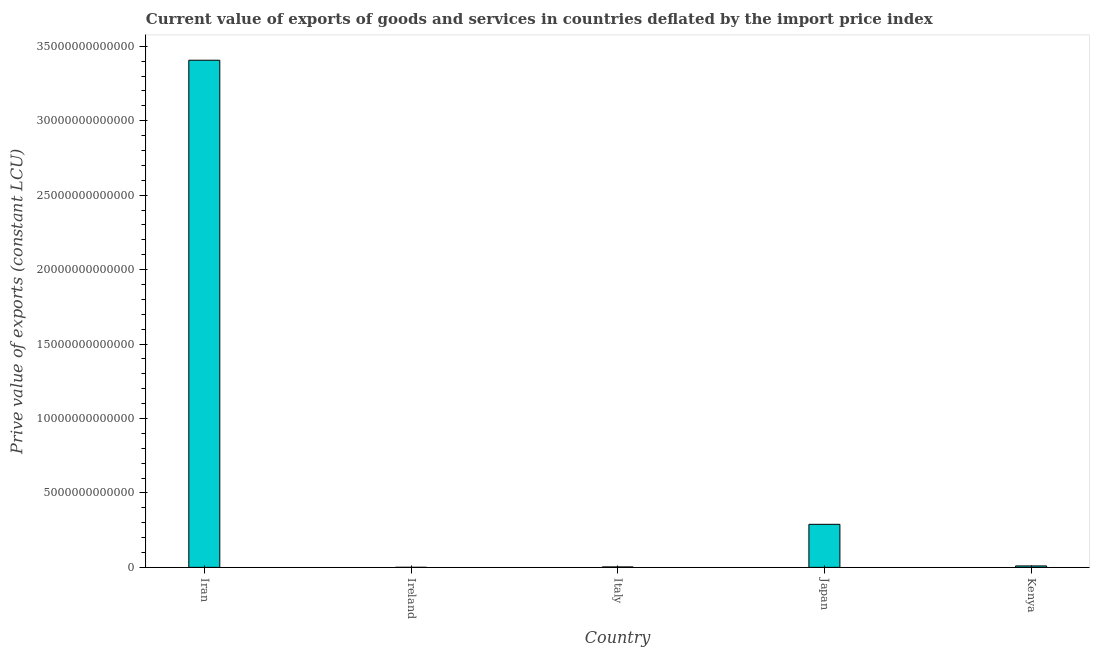Does the graph contain grids?
Give a very brief answer. No. What is the title of the graph?
Ensure brevity in your answer.  Current value of exports of goods and services in countries deflated by the import price index. What is the label or title of the Y-axis?
Provide a succinct answer. Prive value of exports (constant LCU). What is the price value of exports in Italy?
Make the answer very short. 2.88e+1. Across all countries, what is the maximum price value of exports?
Your answer should be very brief. 3.41e+13. Across all countries, what is the minimum price value of exports?
Your answer should be compact. 2.78e+09. In which country was the price value of exports maximum?
Keep it short and to the point. Iran. In which country was the price value of exports minimum?
Your response must be concise. Ireland. What is the sum of the price value of exports?
Offer a terse response. 3.71e+13. What is the difference between the price value of exports in Iran and Italy?
Offer a very short reply. 3.40e+13. What is the average price value of exports per country?
Give a very brief answer. 7.42e+12. What is the median price value of exports?
Your answer should be very brief. 9.59e+1. What is the ratio of the price value of exports in Iran to that in Kenya?
Keep it short and to the point. 355.28. Is the price value of exports in Iran less than that in Ireland?
Provide a short and direct response. No. Is the difference between the price value of exports in Japan and Kenya greater than the difference between any two countries?
Your answer should be very brief. No. What is the difference between the highest and the second highest price value of exports?
Provide a succinct answer. 3.12e+13. What is the difference between the highest and the lowest price value of exports?
Your response must be concise. 3.41e+13. In how many countries, is the price value of exports greater than the average price value of exports taken over all countries?
Make the answer very short. 1. How many bars are there?
Offer a very short reply. 5. Are all the bars in the graph horizontal?
Provide a succinct answer. No. How many countries are there in the graph?
Make the answer very short. 5. What is the difference between two consecutive major ticks on the Y-axis?
Provide a short and direct response. 5.00e+12. What is the Prive value of exports (constant LCU) in Iran?
Your answer should be compact. 3.41e+13. What is the Prive value of exports (constant LCU) of Ireland?
Provide a short and direct response. 2.78e+09. What is the Prive value of exports (constant LCU) of Italy?
Make the answer very short. 2.88e+1. What is the Prive value of exports (constant LCU) of Japan?
Give a very brief answer. 2.89e+12. What is the Prive value of exports (constant LCU) of Kenya?
Your answer should be compact. 9.59e+1. What is the difference between the Prive value of exports (constant LCU) in Iran and Ireland?
Your answer should be very brief. 3.41e+13. What is the difference between the Prive value of exports (constant LCU) in Iran and Italy?
Make the answer very short. 3.40e+13. What is the difference between the Prive value of exports (constant LCU) in Iran and Japan?
Your answer should be very brief. 3.12e+13. What is the difference between the Prive value of exports (constant LCU) in Iran and Kenya?
Your answer should be very brief. 3.40e+13. What is the difference between the Prive value of exports (constant LCU) in Ireland and Italy?
Your answer should be compact. -2.60e+1. What is the difference between the Prive value of exports (constant LCU) in Ireland and Japan?
Your answer should be compact. -2.89e+12. What is the difference between the Prive value of exports (constant LCU) in Ireland and Kenya?
Your answer should be very brief. -9.31e+1. What is the difference between the Prive value of exports (constant LCU) in Italy and Japan?
Provide a succinct answer. -2.86e+12. What is the difference between the Prive value of exports (constant LCU) in Italy and Kenya?
Provide a succinct answer. -6.71e+1. What is the difference between the Prive value of exports (constant LCU) in Japan and Kenya?
Make the answer very short. 2.79e+12. What is the ratio of the Prive value of exports (constant LCU) in Iran to that in Ireland?
Your answer should be very brief. 1.23e+04. What is the ratio of the Prive value of exports (constant LCU) in Iran to that in Italy?
Ensure brevity in your answer.  1182.28. What is the ratio of the Prive value of exports (constant LCU) in Iran to that in Japan?
Your answer should be very brief. 11.78. What is the ratio of the Prive value of exports (constant LCU) in Iran to that in Kenya?
Your answer should be very brief. 355.28. What is the ratio of the Prive value of exports (constant LCU) in Ireland to that in Italy?
Your response must be concise. 0.1. What is the ratio of the Prive value of exports (constant LCU) in Ireland to that in Japan?
Ensure brevity in your answer.  0. What is the ratio of the Prive value of exports (constant LCU) in Ireland to that in Kenya?
Offer a very short reply. 0.03. What is the ratio of the Prive value of exports (constant LCU) in Italy to that in Japan?
Ensure brevity in your answer.  0.01. What is the ratio of the Prive value of exports (constant LCU) in Italy to that in Kenya?
Your answer should be very brief. 0.3. What is the ratio of the Prive value of exports (constant LCU) in Japan to that in Kenya?
Offer a terse response. 30.15. 